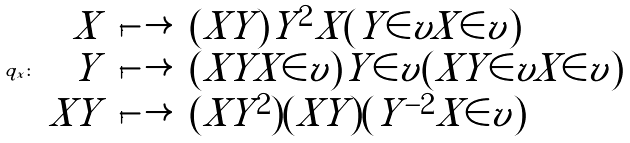<formula> <loc_0><loc_0><loc_500><loc_500>q _ { x } \colon \, \begin{array} { r l l } X & \longmapsto & ( X Y ) Y ^ { 2 } X ( Y \in v X \in v ) \\ Y & \longmapsto & ( X Y X \in v ) Y \in v ( X Y \in v X \in v ) \\ X Y & \longmapsto & ( X Y ^ { 2 } ) ( X Y ) ( Y ^ { - 2 } X \in v ) \end{array}</formula> 